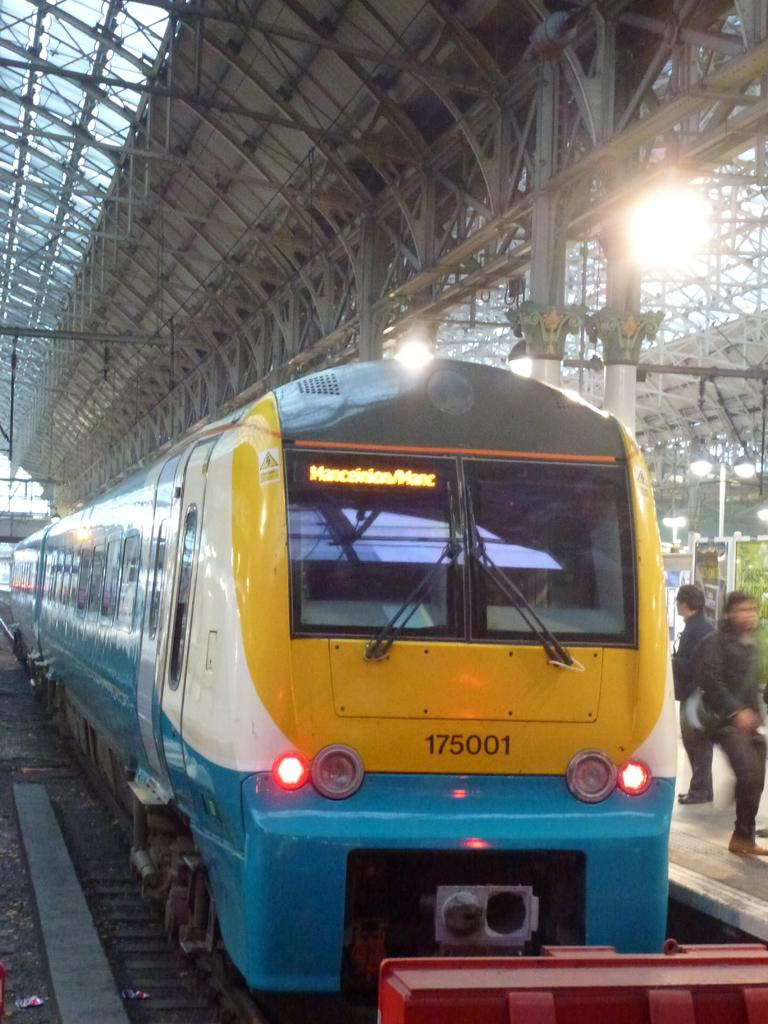What is the main subject of the image? The main subject of the image is a train. What is the train traveling on? The train is traveling on a railway track. Can you describe the light in the image? There is a light in the image, but its specific purpose or type is not clear. Who or what can be seen on the right side of the image? There are two people on the right side of the image. What type of soup is being served in the image? There is no soup present in the image. What appliance is being used by the people on the right side of the image? There is no appliance visible in the image; only the two people are present. 